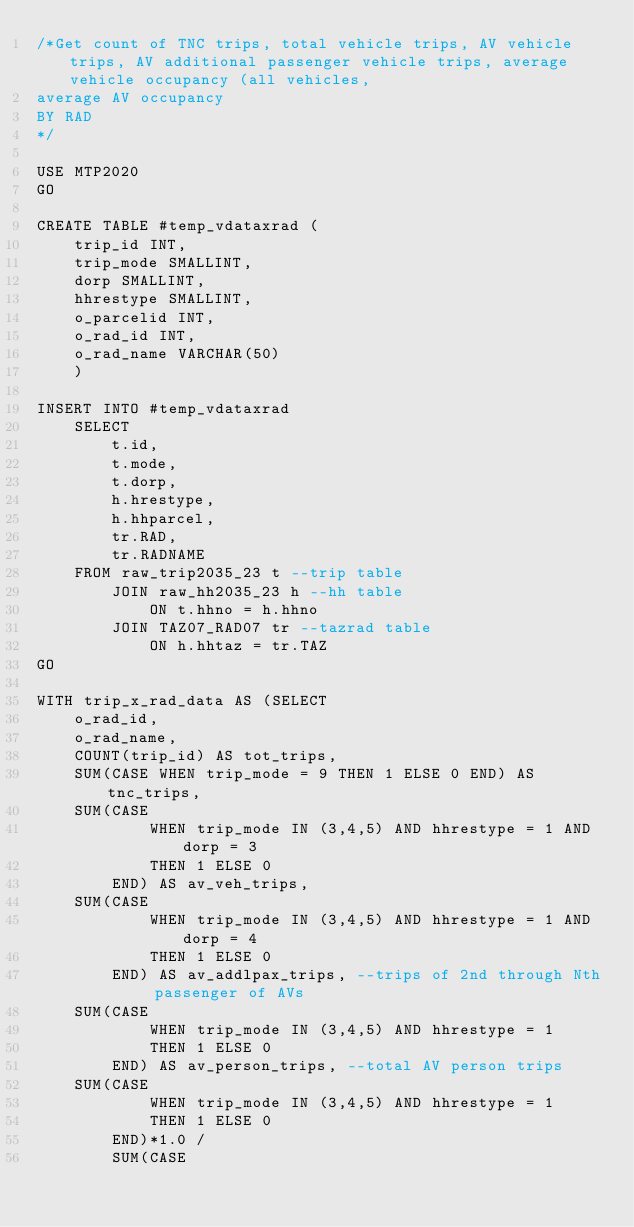<code> <loc_0><loc_0><loc_500><loc_500><_SQL_>/*Get count of TNC trips, total vehicle trips, AV vehicle trips, AV additional passenger vehicle trips, average vehicle occupancy (all vehicles,
average AV occupancy
BY RAD
*/

USE MTP2020
GO

CREATE TABLE #temp_vdataxrad (
	trip_id INT,
	trip_mode SMALLINT,
	dorp SMALLINT,
	hhrestype SMALLINT,
	o_parcelid INT,
	o_rad_id INT,
	o_rad_name VARCHAR(50)
	)

INSERT INTO #temp_vdataxrad
	SELECT
		t.id,
		t.mode,
		t.dorp,
		h.hrestype,
		h.hhparcel,
		tr.RAD,
		tr.RADNAME
	FROM raw_trip2035_23 t --trip table
		JOIN raw_hh2035_23 h --hh table
			ON t.hhno = h.hhno
		JOIN TAZ07_RAD07 tr --tazrad table
			ON h.hhtaz = tr.TAZ
GO

WITH trip_x_rad_data AS (SELECT
	o_rad_id,
	o_rad_name,
	COUNT(trip_id) AS tot_trips,
	SUM(CASE WHEN trip_mode = 9 THEN 1 ELSE 0 END) AS tnc_trips,
	SUM(CASE
			WHEN trip_mode IN (3,4,5) AND hhrestype = 1 AND dorp = 3
			THEN 1 ELSE 0
		END) AS av_veh_trips,
	SUM(CASE
			WHEN trip_mode IN (3,4,5) AND hhrestype = 1 AND dorp = 4
			THEN 1 ELSE 0
		END) AS av_addlpax_trips, --trips of 2nd through Nth passenger of AVs
	SUM(CASE
			WHEN trip_mode IN (3,4,5) AND hhrestype = 1
			THEN 1 ELSE 0
		END) AS av_person_trips, --total AV person trips
	SUM(CASE
			WHEN trip_mode IN (3,4,5) AND hhrestype = 1
			THEN 1 ELSE 0
		END)*1.0 /
		SUM(CASE</code> 